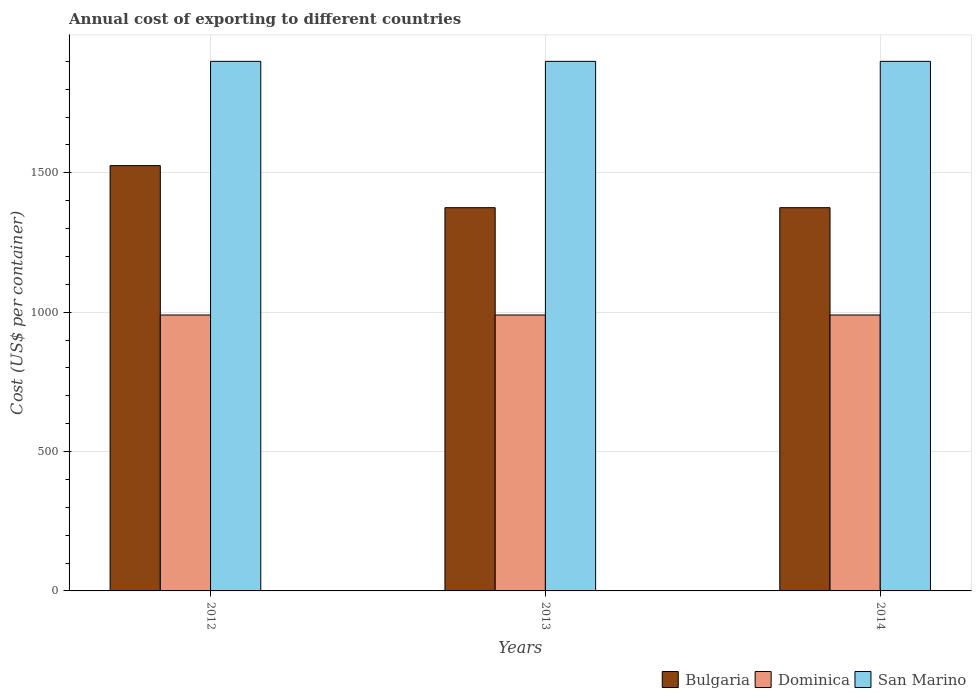Are the number of bars per tick equal to the number of legend labels?
Your response must be concise. Yes. Are the number of bars on each tick of the X-axis equal?
Give a very brief answer. Yes. How many bars are there on the 3rd tick from the right?
Provide a short and direct response. 3. What is the label of the 2nd group of bars from the left?
Keep it short and to the point. 2013. What is the total annual cost of exporting in Dominica in 2012?
Give a very brief answer. 990. Across all years, what is the maximum total annual cost of exporting in Bulgaria?
Ensure brevity in your answer.  1526. Across all years, what is the minimum total annual cost of exporting in Bulgaria?
Offer a terse response. 1375. What is the total total annual cost of exporting in Bulgaria in the graph?
Your answer should be compact. 4276. What is the difference between the total annual cost of exporting in Dominica in 2014 and the total annual cost of exporting in Bulgaria in 2012?
Your answer should be compact. -536. What is the average total annual cost of exporting in Bulgaria per year?
Provide a succinct answer. 1425.33. In the year 2013, what is the difference between the total annual cost of exporting in San Marino and total annual cost of exporting in Bulgaria?
Offer a very short reply. 525. In how many years, is the total annual cost of exporting in Bulgaria greater than 1800 US$?
Provide a succinct answer. 0. What is the difference between the highest and the second highest total annual cost of exporting in Dominica?
Offer a terse response. 0. What is the difference between the highest and the lowest total annual cost of exporting in Bulgaria?
Your answer should be compact. 151. What does the 2nd bar from the left in 2013 represents?
Make the answer very short. Dominica. What does the 2nd bar from the right in 2012 represents?
Keep it short and to the point. Dominica. Is it the case that in every year, the sum of the total annual cost of exporting in San Marino and total annual cost of exporting in Bulgaria is greater than the total annual cost of exporting in Dominica?
Your answer should be compact. Yes. Are all the bars in the graph horizontal?
Give a very brief answer. No. How many years are there in the graph?
Offer a terse response. 3. How many legend labels are there?
Your response must be concise. 3. How are the legend labels stacked?
Ensure brevity in your answer.  Horizontal. What is the title of the graph?
Offer a terse response. Annual cost of exporting to different countries. Does "Somalia" appear as one of the legend labels in the graph?
Offer a very short reply. No. What is the label or title of the X-axis?
Your answer should be very brief. Years. What is the label or title of the Y-axis?
Your response must be concise. Cost (US$ per container). What is the Cost (US$ per container) in Bulgaria in 2012?
Your answer should be compact. 1526. What is the Cost (US$ per container) in Dominica in 2012?
Your answer should be compact. 990. What is the Cost (US$ per container) of San Marino in 2012?
Your answer should be compact. 1900. What is the Cost (US$ per container) in Bulgaria in 2013?
Offer a very short reply. 1375. What is the Cost (US$ per container) in Dominica in 2013?
Your response must be concise. 990. What is the Cost (US$ per container) of San Marino in 2013?
Make the answer very short. 1900. What is the Cost (US$ per container) in Bulgaria in 2014?
Give a very brief answer. 1375. What is the Cost (US$ per container) of Dominica in 2014?
Your answer should be compact. 990. What is the Cost (US$ per container) in San Marino in 2014?
Offer a very short reply. 1900. Across all years, what is the maximum Cost (US$ per container) of Bulgaria?
Your response must be concise. 1526. Across all years, what is the maximum Cost (US$ per container) of Dominica?
Provide a short and direct response. 990. Across all years, what is the maximum Cost (US$ per container) of San Marino?
Give a very brief answer. 1900. Across all years, what is the minimum Cost (US$ per container) of Bulgaria?
Offer a terse response. 1375. Across all years, what is the minimum Cost (US$ per container) of Dominica?
Your answer should be compact. 990. Across all years, what is the minimum Cost (US$ per container) in San Marino?
Give a very brief answer. 1900. What is the total Cost (US$ per container) of Bulgaria in the graph?
Offer a very short reply. 4276. What is the total Cost (US$ per container) of Dominica in the graph?
Give a very brief answer. 2970. What is the total Cost (US$ per container) in San Marino in the graph?
Your response must be concise. 5700. What is the difference between the Cost (US$ per container) of Bulgaria in 2012 and that in 2013?
Offer a terse response. 151. What is the difference between the Cost (US$ per container) of San Marino in 2012 and that in 2013?
Give a very brief answer. 0. What is the difference between the Cost (US$ per container) of Bulgaria in 2012 and that in 2014?
Keep it short and to the point. 151. What is the difference between the Cost (US$ per container) in Bulgaria in 2013 and that in 2014?
Make the answer very short. 0. What is the difference between the Cost (US$ per container) of San Marino in 2013 and that in 2014?
Provide a succinct answer. 0. What is the difference between the Cost (US$ per container) in Bulgaria in 2012 and the Cost (US$ per container) in Dominica in 2013?
Provide a short and direct response. 536. What is the difference between the Cost (US$ per container) of Bulgaria in 2012 and the Cost (US$ per container) of San Marino in 2013?
Offer a terse response. -374. What is the difference between the Cost (US$ per container) in Dominica in 2012 and the Cost (US$ per container) in San Marino in 2013?
Your response must be concise. -910. What is the difference between the Cost (US$ per container) of Bulgaria in 2012 and the Cost (US$ per container) of Dominica in 2014?
Keep it short and to the point. 536. What is the difference between the Cost (US$ per container) of Bulgaria in 2012 and the Cost (US$ per container) of San Marino in 2014?
Provide a short and direct response. -374. What is the difference between the Cost (US$ per container) of Dominica in 2012 and the Cost (US$ per container) of San Marino in 2014?
Provide a succinct answer. -910. What is the difference between the Cost (US$ per container) of Bulgaria in 2013 and the Cost (US$ per container) of Dominica in 2014?
Offer a terse response. 385. What is the difference between the Cost (US$ per container) of Bulgaria in 2013 and the Cost (US$ per container) of San Marino in 2014?
Your answer should be compact. -525. What is the difference between the Cost (US$ per container) of Dominica in 2013 and the Cost (US$ per container) of San Marino in 2014?
Offer a very short reply. -910. What is the average Cost (US$ per container) in Bulgaria per year?
Offer a terse response. 1425.33. What is the average Cost (US$ per container) of Dominica per year?
Provide a succinct answer. 990. What is the average Cost (US$ per container) in San Marino per year?
Provide a succinct answer. 1900. In the year 2012, what is the difference between the Cost (US$ per container) of Bulgaria and Cost (US$ per container) of Dominica?
Your answer should be compact. 536. In the year 2012, what is the difference between the Cost (US$ per container) in Bulgaria and Cost (US$ per container) in San Marino?
Offer a very short reply. -374. In the year 2012, what is the difference between the Cost (US$ per container) in Dominica and Cost (US$ per container) in San Marino?
Ensure brevity in your answer.  -910. In the year 2013, what is the difference between the Cost (US$ per container) of Bulgaria and Cost (US$ per container) of Dominica?
Ensure brevity in your answer.  385. In the year 2013, what is the difference between the Cost (US$ per container) of Bulgaria and Cost (US$ per container) of San Marino?
Keep it short and to the point. -525. In the year 2013, what is the difference between the Cost (US$ per container) in Dominica and Cost (US$ per container) in San Marino?
Give a very brief answer. -910. In the year 2014, what is the difference between the Cost (US$ per container) in Bulgaria and Cost (US$ per container) in Dominica?
Make the answer very short. 385. In the year 2014, what is the difference between the Cost (US$ per container) of Bulgaria and Cost (US$ per container) of San Marino?
Your response must be concise. -525. In the year 2014, what is the difference between the Cost (US$ per container) in Dominica and Cost (US$ per container) in San Marino?
Ensure brevity in your answer.  -910. What is the ratio of the Cost (US$ per container) of Bulgaria in 2012 to that in 2013?
Your answer should be compact. 1.11. What is the ratio of the Cost (US$ per container) in Dominica in 2012 to that in 2013?
Provide a short and direct response. 1. What is the ratio of the Cost (US$ per container) in San Marino in 2012 to that in 2013?
Your response must be concise. 1. What is the ratio of the Cost (US$ per container) in Bulgaria in 2012 to that in 2014?
Give a very brief answer. 1.11. What is the ratio of the Cost (US$ per container) of San Marino in 2012 to that in 2014?
Make the answer very short. 1. What is the ratio of the Cost (US$ per container) of Bulgaria in 2013 to that in 2014?
Ensure brevity in your answer.  1. What is the difference between the highest and the second highest Cost (US$ per container) in Bulgaria?
Offer a terse response. 151. What is the difference between the highest and the lowest Cost (US$ per container) in Bulgaria?
Keep it short and to the point. 151. 